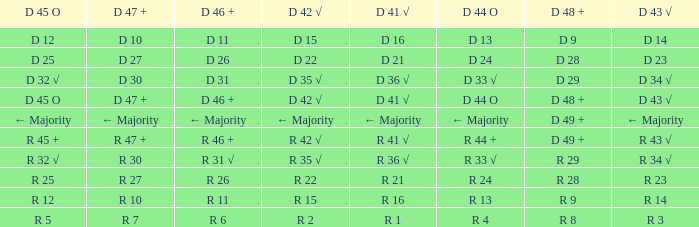What is the value of D 46 +, when the value of D 42 √ is r 2? R 6. 